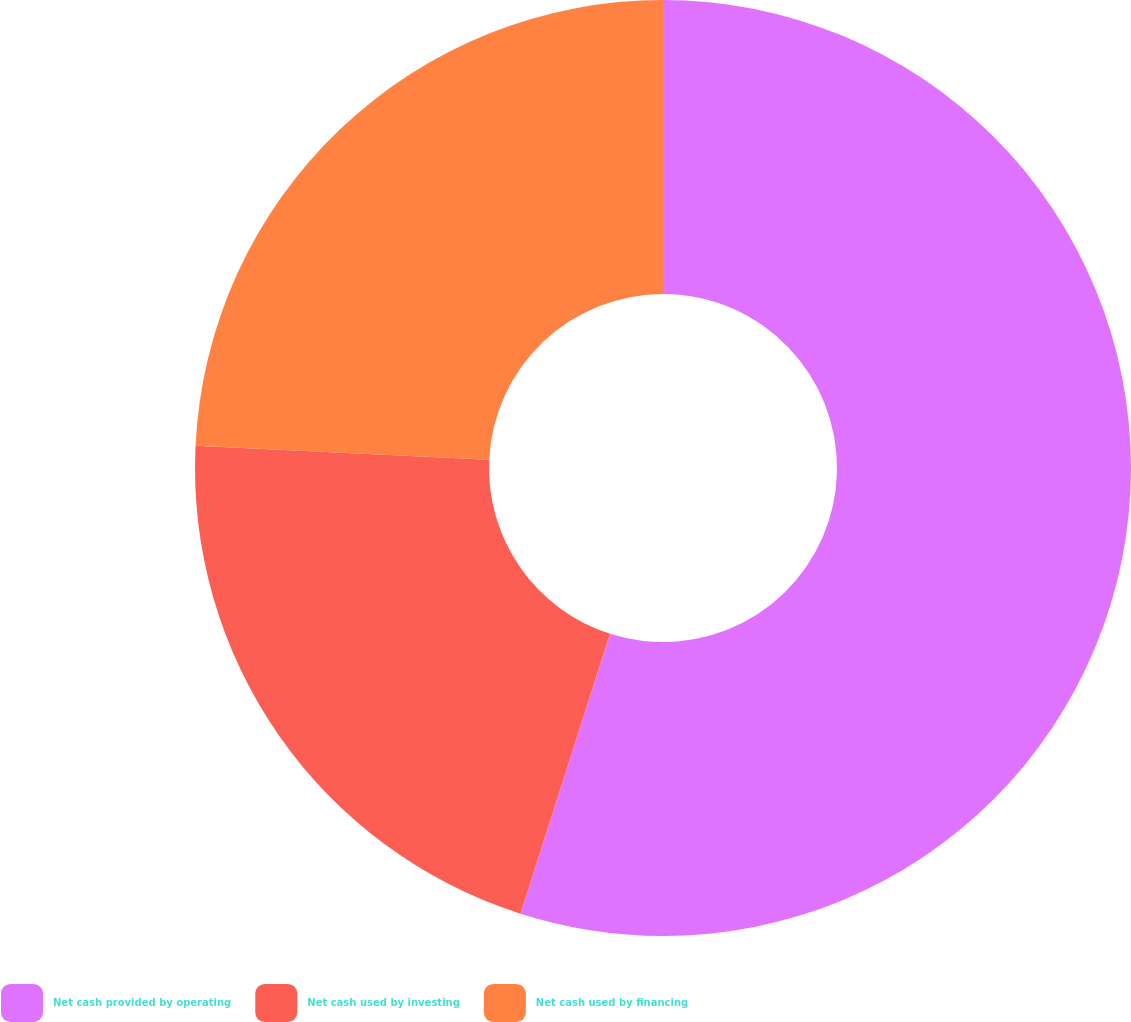Convert chart. <chart><loc_0><loc_0><loc_500><loc_500><pie_chart><fcel>Net cash provided by operating<fcel>Net cash used by investing<fcel>Net cash used by financing<nl><fcel>54.92%<fcel>20.83%<fcel>24.24%<nl></chart> 